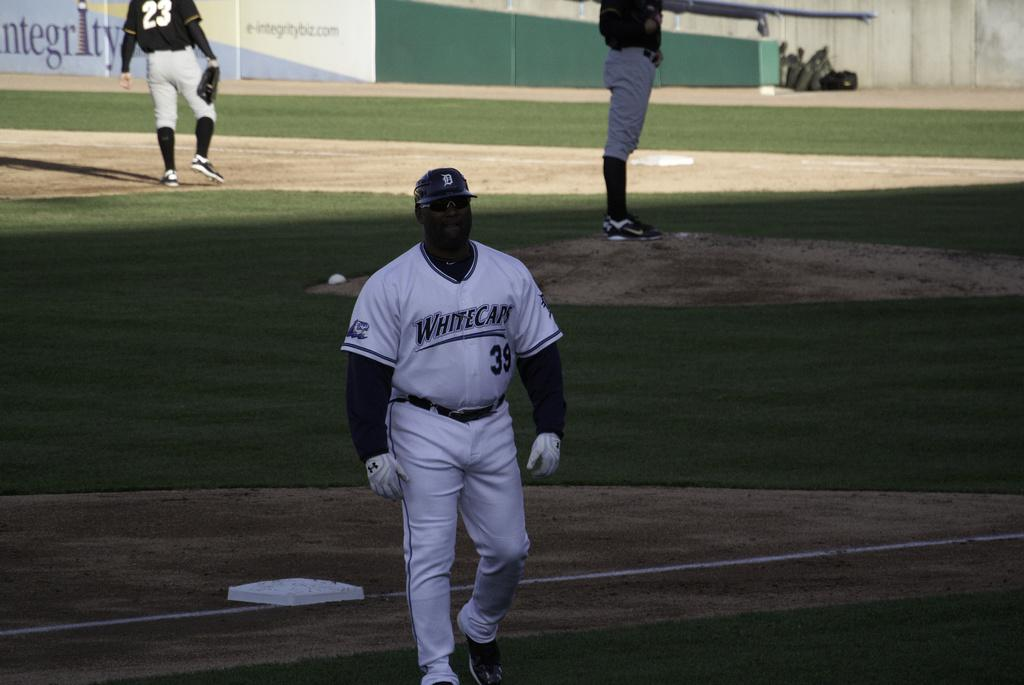Provide a one-sentence caption for the provided image. A man wearing a Whitecaps uniform is walking off a baseball field. 